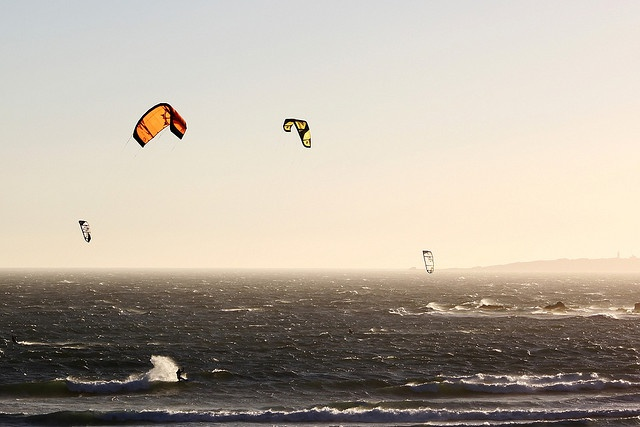Describe the objects in this image and their specific colors. I can see kite in lightgray, orange, black, and maroon tones, kite in lightgray, black, khaki, and white tones, kite in lightgray, beige, and tan tones, kite in lightgray, black, ivory, darkgray, and gray tones, and people in lightgray, black, and gray tones in this image. 